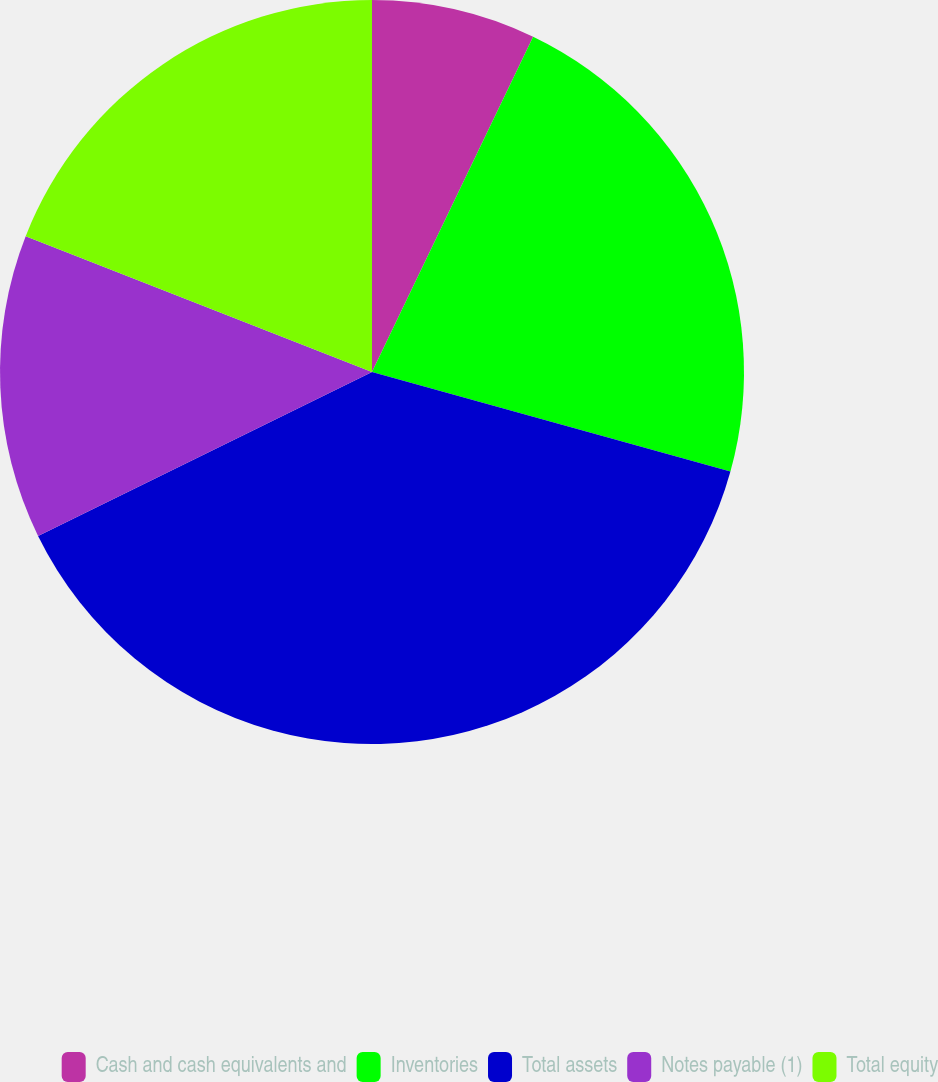<chart> <loc_0><loc_0><loc_500><loc_500><pie_chart><fcel>Cash and cash equivalents and<fcel>Inventories<fcel>Total assets<fcel>Notes payable (1)<fcel>Total equity<nl><fcel>7.13%<fcel>22.18%<fcel>38.42%<fcel>13.21%<fcel>19.05%<nl></chart> 